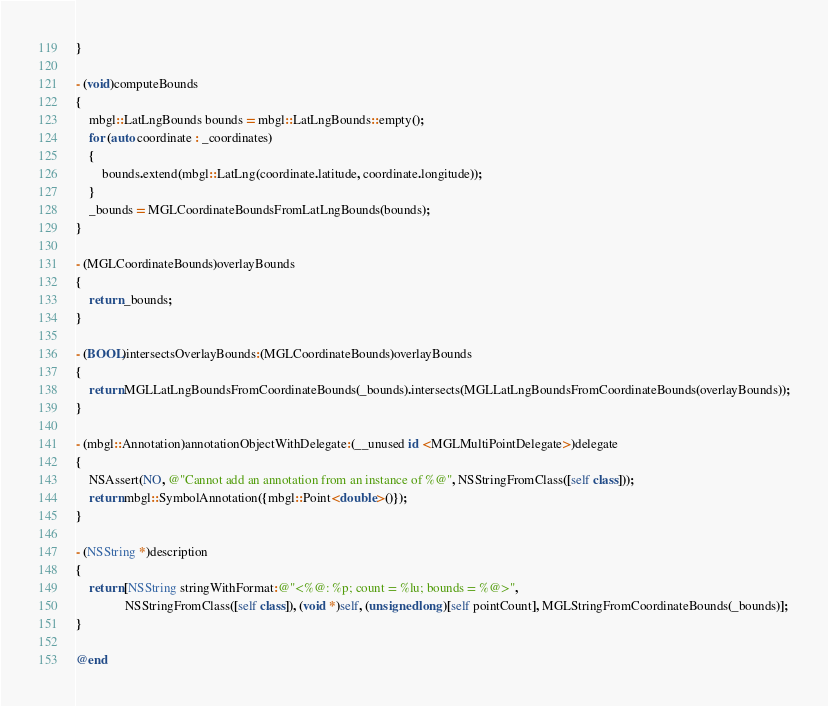<code> <loc_0><loc_0><loc_500><loc_500><_ObjectiveC_>}

- (void)computeBounds
{
    mbgl::LatLngBounds bounds = mbgl::LatLngBounds::empty();
    for (auto coordinate : _coordinates)
    {
        bounds.extend(mbgl::LatLng(coordinate.latitude, coordinate.longitude));
    }
    _bounds = MGLCoordinateBoundsFromLatLngBounds(bounds);
}

- (MGLCoordinateBounds)overlayBounds
{
    return _bounds;
}

- (BOOL)intersectsOverlayBounds:(MGLCoordinateBounds)overlayBounds
{
    return MGLLatLngBoundsFromCoordinateBounds(_bounds).intersects(MGLLatLngBoundsFromCoordinateBounds(overlayBounds));
}

- (mbgl::Annotation)annotationObjectWithDelegate:(__unused id <MGLMultiPointDelegate>)delegate
{
    NSAssert(NO, @"Cannot add an annotation from an instance of %@", NSStringFromClass([self class]));
    return mbgl::SymbolAnnotation({mbgl::Point<double>()});
}

- (NSString *)description
{
    return [NSString stringWithFormat:@"<%@: %p; count = %lu; bounds = %@>",
               NSStringFromClass([self class]), (void *)self, (unsigned long)[self pointCount], MGLStringFromCoordinateBounds(_bounds)];
}

@end
</code> 